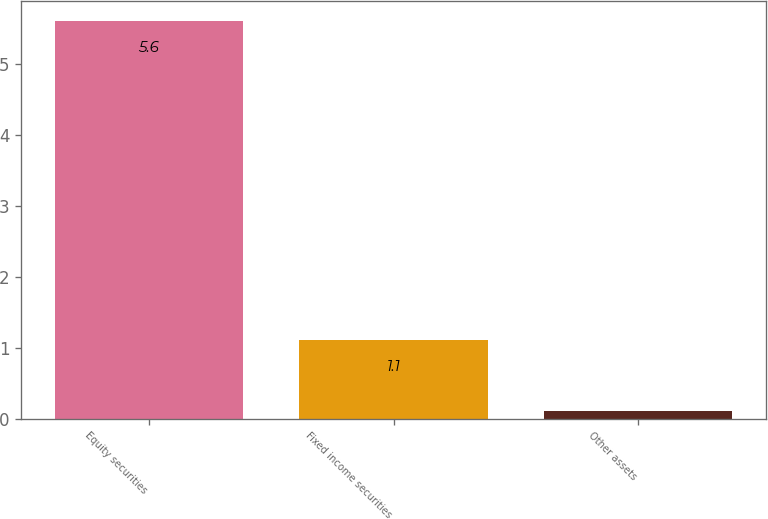<chart> <loc_0><loc_0><loc_500><loc_500><bar_chart><fcel>Equity securities<fcel>Fixed income securities<fcel>Other assets<nl><fcel>5.6<fcel>1.1<fcel>0.1<nl></chart> 